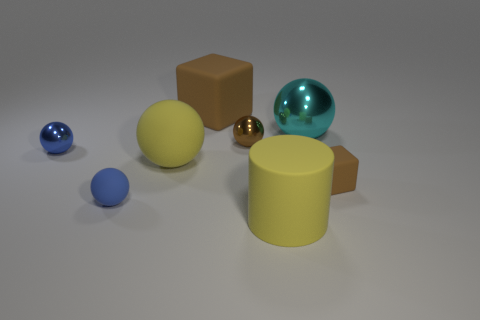Add 1 large red metallic spheres. How many objects exist? 9 Subtract all tiny brown metallic spheres. How many spheres are left? 4 Subtract all yellow spheres. How many spheres are left? 4 Add 4 tiny brown matte things. How many tiny brown matte things exist? 5 Subtract 1 brown balls. How many objects are left? 7 Subtract all cylinders. How many objects are left? 7 Subtract 1 blocks. How many blocks are left? 1 Subtract all brown spheres. Subtract all purple cylinders. How many spheres are left? 4 Subtract all gray cubes. How many yellow balls are left? 1 Subtract all tiny rubber objects. Subtract all small blue matte objects. How many objects are left? 5 